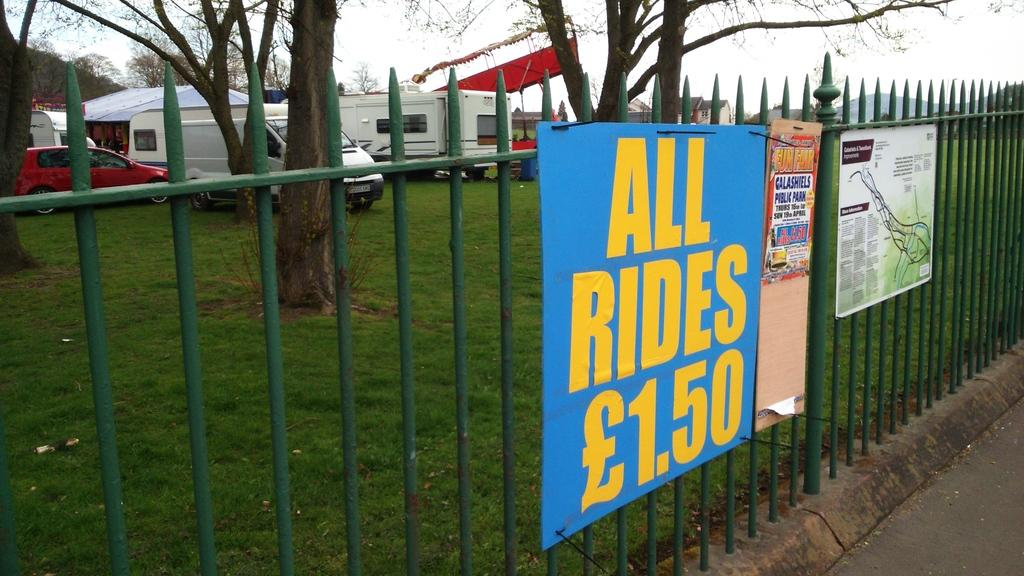What separates the two sides of the image? There is a boundary in the center of the image. What is placed on the boundary? There are posters on the boundary. What can be seen in the distance in the image? There are vehicles and trees in the background of the image. Who is the expert in the image? There is no expert present in the image. What type of milk is being served in the image? There is no milk present in the image. 